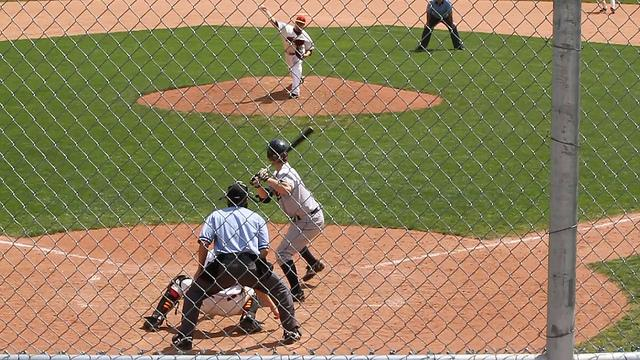The fence is placed in front of what part of the stadium to stop the pitchers fastball from hitting it?

Choices:
A) fans
B) all correct
C) stands
D) audience all correct 